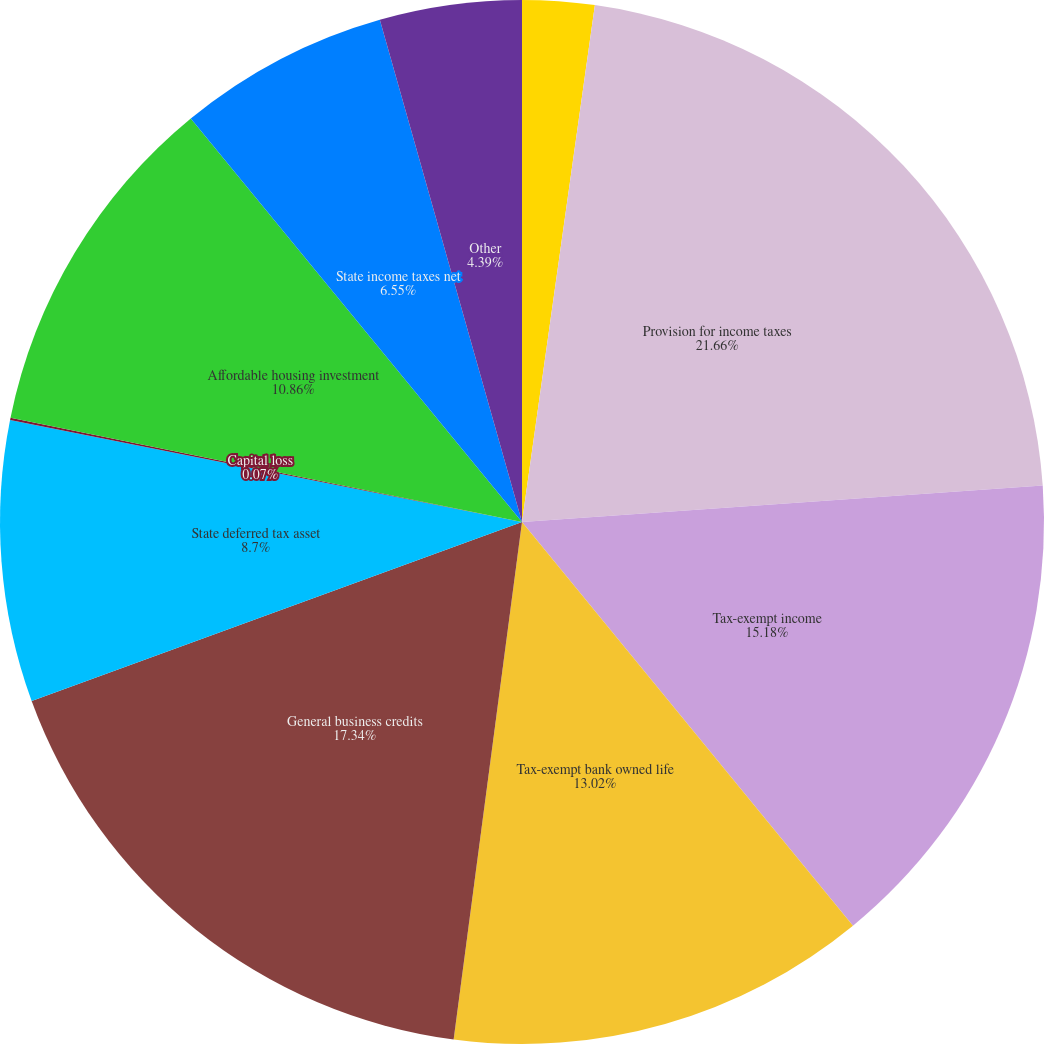Convert chart to OTSL. <chart><loc_0><loc_0><loc_500><loc_500><pie_chart><fcel>(dollar amounts in thousands)<fcel>Provision for income taxes<fcel>Tax-exempt income<fcel>Tax-exempt bank owned life<fcel>General business credits<fcel>State deferred tax asset<fcel>Capital loss<fcel>Affordable housing investment<fcel>State income taxes net<fcel>Other<nl><fcel>2.23%<fcel>21.66%<fcel>15.18%<fcel>13.02%<fcel>17.34%<fcel>8.7%<fcel>0.07%<fcel>10.86%<fcel>6.55%<fcel>4.39%<nl></chart> 